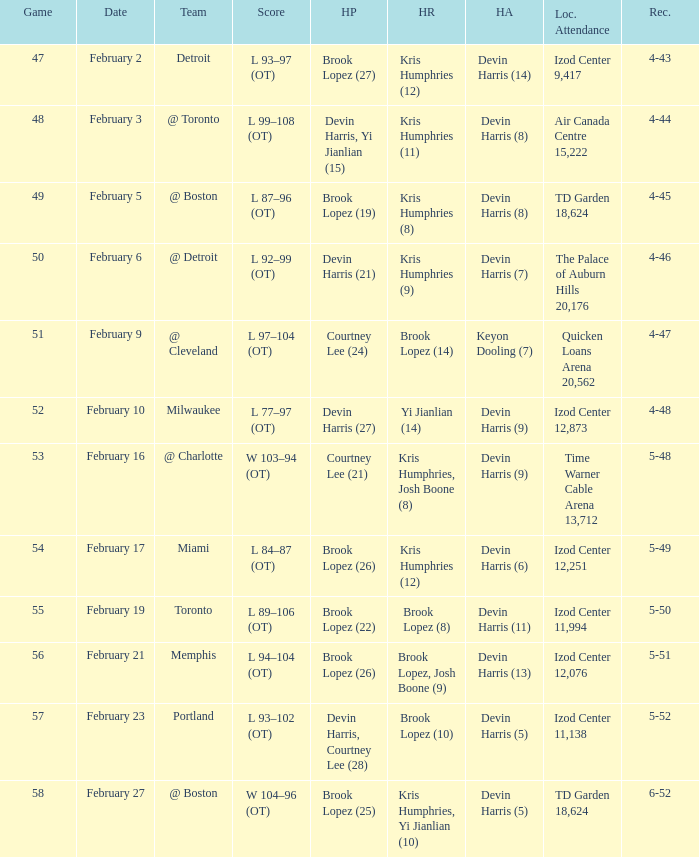What's the highest game number for a game in which Kris Humphries (8) did the high rebounds? 49.0. 